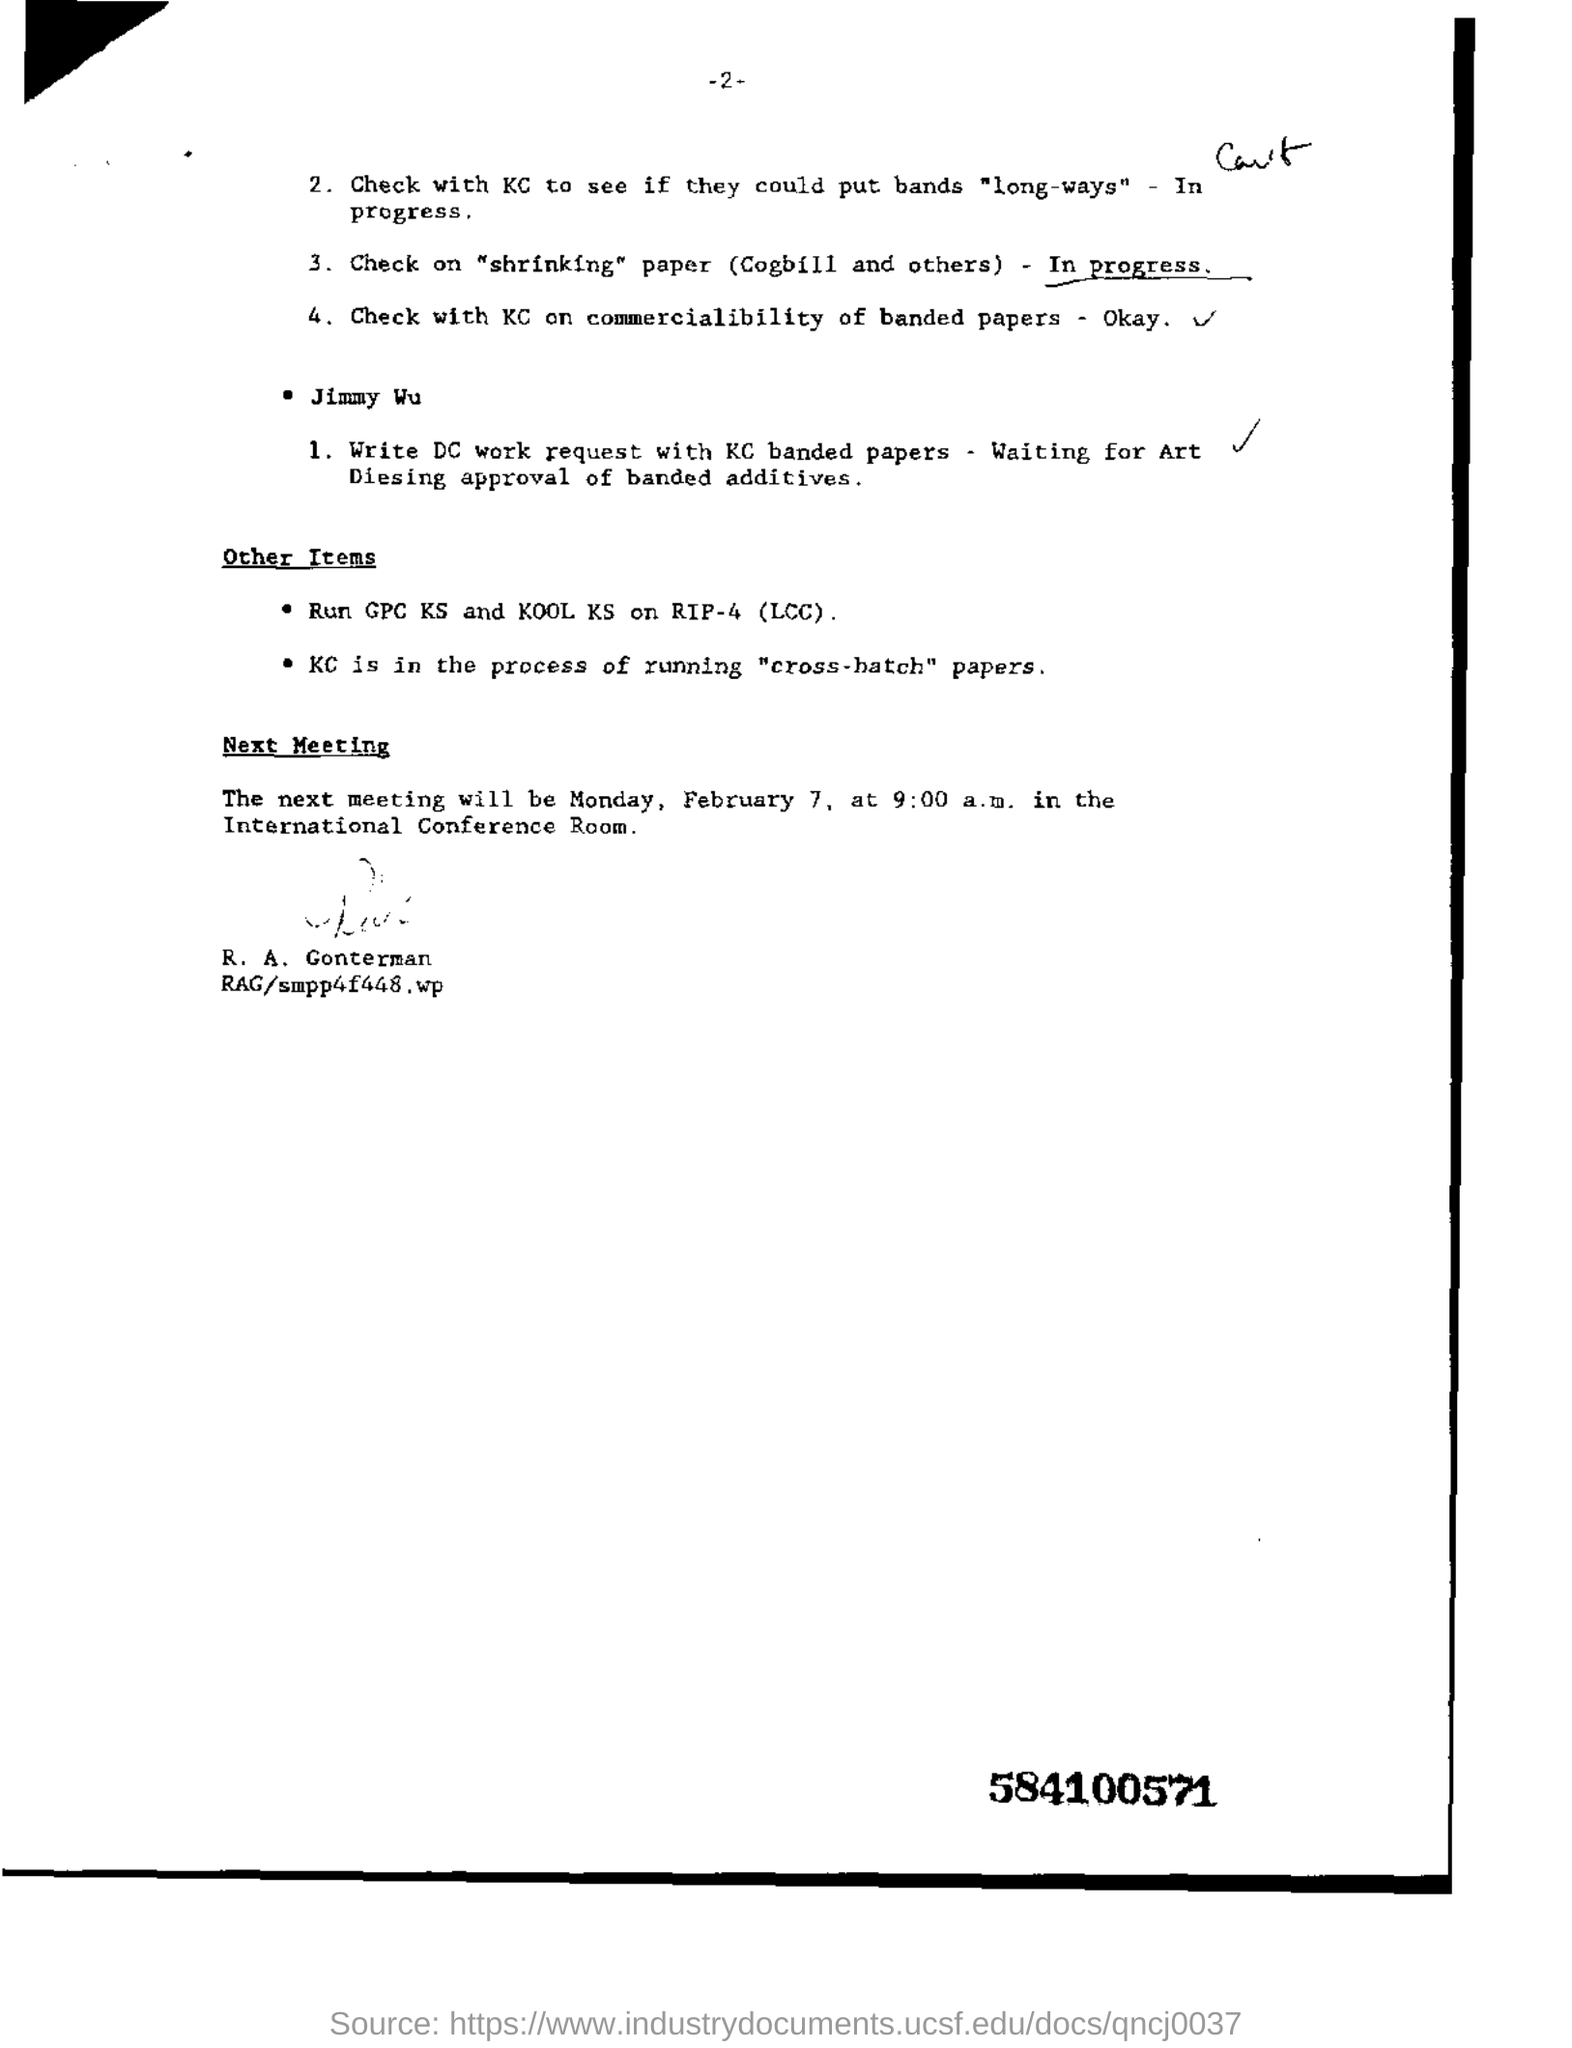Mention a couple of crucial points in this snapshot. The next meeting will take place on Monday, February 7, at 9:00 a.m. The DC work request should be written using KC Banded papers. The meeting will be held in the International Conference Room. The question asks for the code found in the bottom right corner of a piece of text, which is 584100571. 